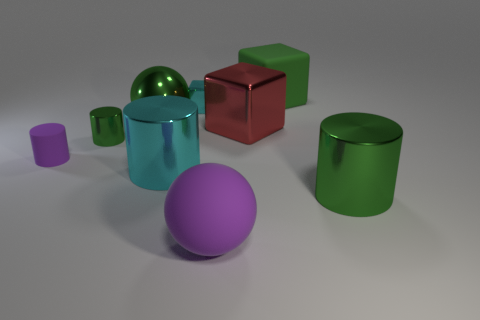Subtract all brown cubes. How many green cylinders are left? 2 Subtract all purple matte cylinders. How many cylinders are left? 3 Subtract all purple cylinders. How many cylinders are left? 3 Add 1 large cyan objects. How many objects exist? 10 Subtract all purple cylinders. Subtract all cyan spheres. How many cylinders are left? 3 Subtract all cubes. How many objects are left? 6 Add 4 tiny cyan shiny blocks. How many tiny cyan shiny blocks are left? 5 Add 7 small yellow metal cylinders. How many small yellow metal cylinders exist? 7 Subtract 0 yellow balls. How many objects are left? 9 Subtract all tiny metal spheres. Subtract all green balls. How many objects are left? 8 